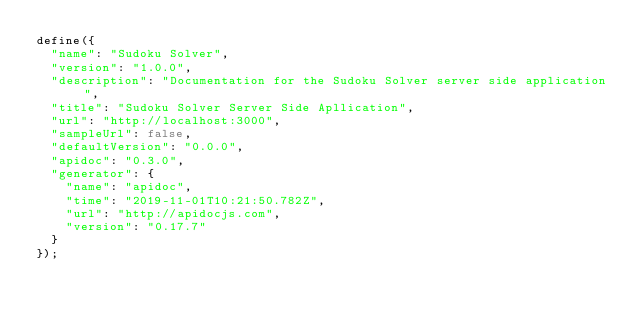<code> <loc_0><loc_0><loc_500><loc_500><_JavaScript_>define({
  "name": "Sudoku Solver",
  "version": "1.0.0",
  "description": "Documentation for the Sudoku Solver server side application",
  "title": "Sudoku Solver Server Side Apllication",
  "url": "http://localhost:3000",
  "sampleUrl": false,
  "defaultVersion": "0.0.0",
  "apidoc": "0.3.0",
  "generator": {
    "name": "apidoc",
    "time": "2019-11-01T10:21:50.782Z",
    "url": "http://apidocjs.com",
    "version": "0.17.7"
  }
});
</code> 